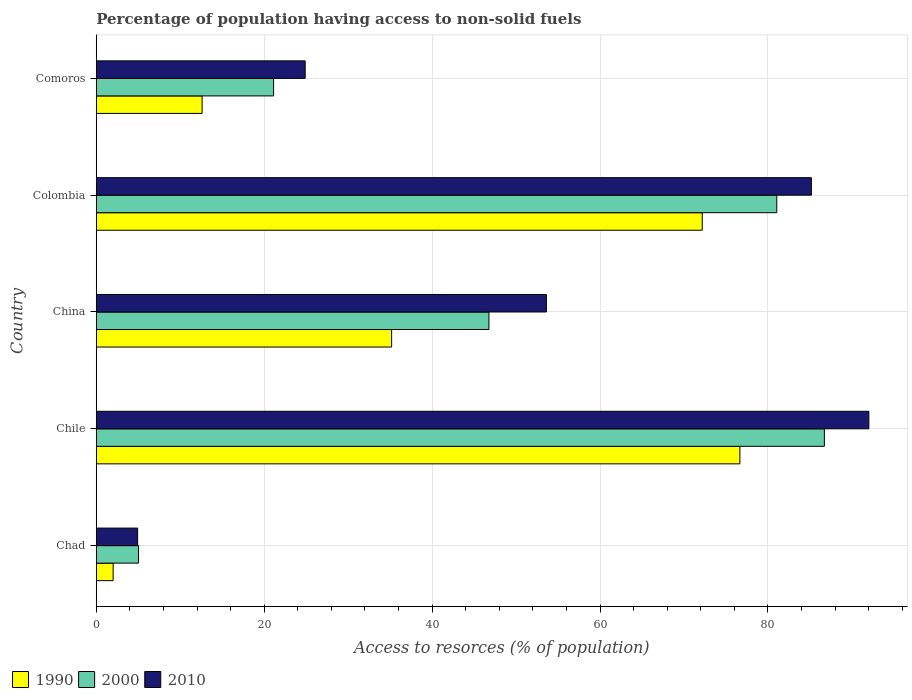How many groups of bars are there?
Offer a terse response. 5. How many bars are there on the 2nd tick from the top?
Your answer should be very brief. 3. What is the label of the 3rd group of bars from the top?
Give a very brief answer. China. What is the percentage of population having access to non-solid fuels in 1990 in China?
Ensure brevity in your answer.  35.18. Across all countries, what is the maximum percentage of population having access to non-solid fuels in 1990?
Offer a very short reply. 76.66. Across all countries, what is the minimum percentage of population having access to non-solid fuels in 2010?
Keep it short and to the point. 4.92. In which country was the percentage of population having access to non-solid fuels in 2010 maximum?
Give a very brief answer. Chile. In which country was the percentage of population having access to non-solid fuels in 2000 minimum?
Your answer should be very brief. Chad. What is the total percentage of population having access to non-solid fuels in 2010 in the graph?
Offer a very short reply. 260.61. What is the difference between the percentage of population having access to non-solid fuels in 2010 in Chile and that in Colombia?
Give a very brief answer. 6.85. What is the difference between the percentage of population having access to non-solid fuels in 1990 in China and the percentage of population having access to non-solid fuels in 2000 in Colombia?
Provide a succinct answer. -45.87. What is the average percentage of population having access to non-solid fuels in 2000 per country?
Offer a terse response. 48.14. What is the difference between the percentage of population having access to non-solid fuels in 1990 and percentage of population having access to non-solid fuels in 2010 in China?
Your response must be concise. -18.43. In how many countries, is the percentage of population having access to non-solid fuels in 2010 greater than 44 %?
Your answer should be very brief. 3. What is the ratio of the percentage of population having access to non-solid fuels in 2010 in China to that in Colombia?
Keep it short and to the point. 0.63. Is the percentage of population having access to non-solid fuels in 2010 in Chad less than that in Colombia?
Your answer should be very brief. Yes. Is the difference between the percentage of population having access to non-solid fuels in 1990 in Chile and Colombia greater than the difference between the percentage of population having access to non-solid fuels in 2010 in Chile and Colombia?
Provide a succinct answer. No. What is the difference between the highest and the second highest percentage of population having access to non-solid fuels in 1990?
Give a very brief answer. 4.49. What is the difference between the highest and the lowest percentage of population having access to non-solid fuels in 2010?
Your response must be concise. 87.09. In how many countries, is the percentage of population having access to non-solid fuels in 2000 greater than the average percentage of population having access to non-solid fuels in 2000 taken over all countries?
Offer a terse response. 2. Is the sum of the percentage of population having access to non-solid fuels in 2010 in Chile and China greater than the maximum percentage of population having access to non-solid fuels in 2000 across all countries?
Give a very brief answer. Yes. What does the 1st bar from the top in Chad represents?
Ensure brevity in your answer.  2010. What does the 3rd bar from the bottom in China represents?
Offer a terse response. 2010. Is it the case that in every country, the sum of the percentage of population having access to non-solid fuels in 1990 and percentage of population having access to non-solid fuels in 2010 is greater than the percentage of population having access to non-solid fuels in 2000?
Ensure brevity in your answer.  Yes. What is the difference between two consecutive major ticks on the X-axis?
Provide a succinct answer. 20. Are the values on the major ticks of X-axis written in scientific E-notation?
Offer a very short reply. No. Where does the legend appear in the graph?
Provide a short and direct response. Bottom left. How many legend labels are there?
Ensure brevity in your answer.  3. How are the legend labels stacked?
Your answer should be very brief. Horizontal. What is the title of the graph?
Offer a very short reply. Percentage of population having access to non-solid fuels. Does "1998" appear as one of the legend labels in the graph?
Your answer should be very brief. No. What is the label or title of the X-axis?
Your answer should be very brief. Access to resorces (% of population). What is the label or title of the Y-axis?
Ensure brevity in your answer.  Country. What is the Access to resorces (% of population) in 1990 in Chad?
Give a very brief answer. 2.01. What is the Access to resorces (% of population) in 2000 in Chad?
Your answer should be compact. 5.04. What is the Access to resorces (% of population) in 2010 in Chad?
Your response must be concise. 4.92. What is the Access to resorces (% of population) of 1990 in Chile?
Ensure brevity in your answer.  76.66. What is the Access to resorces (% of population) of 2000 in Chile?
Keep it short and to the point. 86.72. What is the Access to resorces (% of population) of 2010 in Chile?
Offer a terse response. 92.02. What is the Access to resorces (% of population) in 1990 in China?
Your response must be concise. 35.18. What is the Access to resorces (% of population) in 2000 in China?
Your response must be concise. 46.77. What is the Access to resorces (% of population) of 2010 in China?
Your answer should be very brief. 53.61. What is the Access to resorces (% of population) of 1990 in Colombia?
Your response must be concise. 72.17. What is the Access to resorces (% of population) in 2000 in Colombia?
Offer a terse response. 81.05. What is the Access to resorces (% of population) in 2010 in Colombia?
Your answer should be compact. 85.17. What is the Access to resorces (% of population) of 1990 in Comoros?
Provide a succinct answer. 12.61. What is the Access to resorces (% of population) in 2000 in Comoros?
Your answer should be very brief. 21.12. What is the Access to resorces (% of population) of 2010 in Comoros?
Keep it short and to the point. 24.88. Across all countries, what is the maximum Access to resorces (% of population) in 1990?
Ensure brevity in your answer.  76.66. Across all countries, what is the maximum Access to resorces (% of population) in 2000?
Keep it short and to the point. 86.72. Across all countries, what is the maximum Access to resorces (% of population) in 2010?
Ensure brevity in your answer.  92.02. Across all countries, what is the minimum Access to resorces (% of population) in 1990?
Provide a short and direct response. 2.01. Across all countries, what is the minimum Access to resorces (% of population) of 2000?
Keep it short and to the point. 5.04. Across all countries, what is the minimum Access to resorces (% of population) in 2010?
Ensure brevity in your answer.  4.92. What is the total Access to resorces (% of population) of 1990 in the graph?
Keep it short and to the point. 198.62. What is the total Access to resorces (% of population) in 2000 in the graph?
Give a very brief answer. 240.69. What is the total Access to resorces (% of population) in 2010 in the graph?
Your answer should be compact. 260.61. What is the difference between the Access to resorces (% of population) of 1990 in Chad and that in Chile?
Make the answer very short. -74.65. What is the difference between the Access to resorces (% of population) of 2000 in Chad and that in Chile?
Offer a terse response. -81.68. What is the difference between the Access to resorces (% of population) of 2010 in Chad and that in Chile?
Your response must be concise. -87.09. What is the difference between the Access to resorces (% of population) in 1990 in Chad and that in China?
Your response must be concise. -33.17. What is the difference between the Access to resorces (% of population) of 2000 in Chad and that in China?
Your answer should be compact. -41.73. What is the difference between the Access to resorces (% of population) of 2010 in Chad and that in China?
Your answer should be compact. -48.69. What is the difference between the Access to resorces (% of population) in 1990 in Chad and that in Colombia?
Keep it short and to the point. -70.16. What is the difference between the Access to resorces (% of population) in 2000 in Chad and that in Colombia?
Offer a very short reply. -76.01. What is the difference between the Access to resorces (% of population) of 2010 in Chad and that in Colombia?
Make the answer very short. -80.25. What is the difference between the Access to resorces (% of population) in 1990 in Chad and that in Comoros?
Your response must be concise. -10.6. What is the difference between the Access to resorces (% of population) in 2000 in Chad and that in Comoros?
Provide a short and direct response. -16.09. What is the difference between the Access to resorces (% of population) in 2010 in Chad and that in Comoros?
Your answer should be very brief. -19.96. What is the difference between the Access to resorces (% of population) of 1990 in Chile and that in China?
Offer a very short reply. 41.48. What is the difference between the Access to resorces (% of population) of 2000 in Chile and that in China?
Your answer should be very brief. 39.95. What is the difference between the Access to resorces (% of population) of 2010 in Chile and that in China?
Provide a short and direct response. 38.41. What is the difference between the Access to resorces (% of population) in 1990 in Chile and that in Colombia?
Provide a short and direct response. 4.49. What is the difference between the Access to resorces (% of population) in 2000 in Chile and that in Colombia?
Provide a short and direct response. 5.67. What is the difference between the Access to resorces (% of population) of 2010 in Chile and that in Colombia?
Your response must be concise. 6.85. What is the difference between the Access to resorces (% of population) in 1990 in Chile and that in Comoros?
Your answer should be compact. 64.05. What is the difference between the Access to resorces (% of population) in 2000 in Chile and that in Comoros?
Make the answer very short. 65.6. What is the difference between the Access to resorces (% of population) in 2010 in Chile and that in Comoros?
Your answer should be very brief. 67.13. What is the difference between the Access to resorces (% of population) in 1990 in China and that in Colombia?
Provide a short and direct response. -36.99. What is the difference between the Access to resorces (% of population) of 2000 in China and that in Colombia?
Provide a short and direct response. -34.28. What is the difference between the Access to resorces (% of population) in 2010 in China and that in Colombia?
Offer a very short reply. -31.56. What is the difference between the Access to resorces (% of population) in 1990 in China and that in Comoros?
Keep it short and to the point. 22.57. What is the difference between the Access to resorces (% of population) of 2000 in China and that in Comoros?
Provide a short and direct response. 25.65. What is the difference between the Access to resorces (% of population) in 2010 in China and that in Comoros?
Your answer should be very brief. 28.73. What is the difference between the Access to resorces (% of population) of 1990 in Colombia and that in Comoros?
Your response must be concise. 59.57. What is the difference between the Access to resorces (% of population) in 2000 in Colombia and that in Comoros?
Keep it short and to the point. 59.93. What is the difference between the Access to resorces (% of population) in 2010 in Colombia and that in Comoros?
Offer a very short reply. 60.29. What is the difference between the Access to resorces (% of population) in 1990 in Chad and the Access to resorces (% of population) in 2000 in Chile?
Provide a succinct answer. -84.71. What is the difference between the Access to resorces (% of population) of 1990 in Chad and the Access to resorces (% of population) of 2010 in Chile?
Offer a very short reply. -90.01. What is the difference between the Access to resorces (% of population) of 2000 in Chad and the Access to resorces (% of population) of 2010 in Chile?
Give a very brief answer. -86.98. What is the difference between the Access to resorces (% of population) of 1990 in Chad and the Access to resorces (% of population) of 2000 in China?
Give a very brief answer. -44.76. What is the difference between the Access to resorces (% of population) of 1990 in Chad and the Access to resorces (% of population) of 2010 in China?
Your answer should be very brief. -51.6. What is the difference between the Access to resorces (% of population) in 2000 in Chad and the Access to resorces (% of population) in 2010 in China?
Your answer should be very brief. -48.58. What is the difference between the Access to resorces (% of population) of 1990 in Chad and the Access to resorces (% of population) of 2000 in Colombia?
Your response must be concise. -79.04. What is the difference between the Access to resorces (% of population) of 1990 in Chad and the Access to resorces (% of population) of 2010 in Colombia?
Provide a short and direct response. -83.16. What is the difference between the Access to resorces (% of population) in 2000 in Chad and the Access to resorces (% of population) in 2010 in Colombia?
Keep it short and to the point. -80.14. What is the difference between the Access to resorces (% of population) of 1990 in Chad and the Access to resorces (% of population) of 2000 in Comoros?
Your response must be concise. -19.11. What is the difference between the Access to resorces (% of population) in 1990 in Chad and the Access to resorces (% of population) in 2010 in Comoros?
Make the answer very short. -22.87. What is the difference between the Access to resorces (% of population) of 2000 in Chad and the Access to resorces (% of population) of 2010 in Comoros?
Make the answer very short. -19.85. What is the difference between the Access to resorces (% of population) in 1990 in Chile and the Access to resorces (% of population) in 2000 in China?
Offer a very short reply. 29.89. What is the difference between the Access to resorces (% of population) in 1990 in Chile and the Access to resorces (% of population) in 2010 in China?
Give a very brief answer. 23.05. What is the difference between the Access to resorces (% of population) of 2000 in Chile and the Access to resorces (% of population) of 2010 in China?
Offer a very short reply. 33.11. What is the difference between the Access to resorces (% of population) in 1990 in Chile and the Access to resorces (% of population) in 2000 in Colombia?
Provide a succinct answer. -4.39. What is the difference between the Access to resorces (% of population) of 1990 in Chile and the Access to resorces (% of population) of 2010 in Colombia?
Offer a very short reply. -8.51. What is the difference between the Access to resorces (% of population) in 2000 in Chile and the Access to resorces (% of population) in 2010 in Colombia?
Your response must be concise. 1.55. What is the difference between the Access to resorces (% of population) in 1990 in Chile and the Access to resorces (% of population) in 2000 in Comoros?
Offer a very short reply. 55.54. What is the difference between the Access to resorces (% of population) of 1990 in Chile and the Access to resorces (% of population) of 2010 in Comoros?
Make the answer very short. 51.77. What is the difference between the Access to resorces (% of population) in 2000 in Chile and the Access to resorces (% of population) in 2010 in Comoros?
Give a very brief answer. 61.84. What is the difference between the Access to resorces (% of population) of 1990 in China and the Access to resorces (% of population) of 2000 in Colombia?
Your answer should be compact. -45.87. What is the difference between the Access to resorces (% of population) of 1990 in China and the Access to resorces (% of population) of 2010 in Colombia?
Your response must be concise. -49.99. What is the difference between the Access to resorces (% of population) of 2000 in China and the Access to resorces (% of population) of 2010 in Colombia?
Provide a short and direct response. -38.4. What is the difference between the Access to resorces (% of population) in 1990 in China and the Access to resorces (% of population) in 2000 in Comoros?
Keep it short and to the point. 14.06. What is the difference between the Access to resorces (% of population) of 1990 in China and the Access to resorces (% of population) of 2010 in Comoros?
Offer a very short reply. 10.29. What is the difference between the Access to resorces (% of population) in 2000 in China and the Access to resorces (% of population) in 2010 in Comoros?
Give a very brief answer. 21.88. What is the difference between the Access to resorces (% of population) in 1990 in Colombia and the Access to resorces (% of population) in 2000 in Comoros?
Your answer should be compact. 51.05. What is the difference between the Access to resorces (% of population) of 1990 in Colombia and the Access to resorces (% of population) of 2010 in Comoros?
Make the answer very short. 47.29. What is the difference between the Access to resorces (% of population) of 2000 in Colombia and the Access to resorces (% of population) of 2010 in Comoros?
Offer a terse response. 56.16. What is the average Access to resorces (% of population) of 1990 per country?
Your response must be concise. 39.72. What is the average Access to resorces (% of population) of 2000 per country?
Give a very brief answer. 48.14. What is the average Access to resorces (% of population) of 2010 per country?
Provide a short and direct response. 52.12. What is the difference between the Access to resorces (% of population) in 1990 and Access to resorces (% of population) in 2000 in Chad?
Your answer should be compact. -3.03. What is the difference between the Access to resorces (% of population) in 1990 and Access to resorces (% of population) in 2010 in Chad?
Make the answer very short. -2.92. What is the difference between the Access to resorces (% of population) in 2000 and Access to resorces (% of population) in 2010 in Chad?
Your response must be concise. 0.11. What is the difference between the Access to resorces (% of population) of 1990 and Access to resorces (% of population) of 2000 in Chile?
Offer a very short reply. -10.06. What is the difference between the Access to resorces (% of population) in 1990 and Access to resorces (% of population) in 2010 in Chile?
Your answer should be compact. -15.36. What is the difference between the Access to resorces (% of population) of 2000 and Access to resorces (% of population) of 2010 in Chile?
Offer a terse response. -5.3. What is the difference between the Access to resorces (% of population) of 1990 and Access to resorces (% of population) of 2000 in China?
Keep it short and to the point. -11.59. What is the difference between the Access to resorces (% of population) of 1990 and Access to resorces (% of population) of 2010 in China?
Your answer should be compact. -18.43. What is the difference between the Access to resorces (% of population) in 2000 and Access to resorces (% of population) in 2010 in China?
Provide a succinct answer. -6.84. What is the difference between the Access to resorces (% of population) in 1990 and Access to resorces (% of population) in 2000 in Colombia?
Offer a terse response. -8.88. What is the difference between the Access to resorces (% of population) of 1990 and Access to resorces (% of population) of 2010 in Colombia?
Provide a short and direct response. -13. What is the difference between the Access to resorces (% of population) of 2000 and Access to resorces (% of population) of 2010 in Colombia?
Offer a very short reply. -4.12. What is the difference between the Access to resorces (% of population) of 1990 and Access to resorces (% of population) of 2000 in Comoros?
Your answer should be very brief. -8.52. What is the difference between the Access to resorces (% of population) in 1990 and Access to resorces (% of population) in 2010 in Comoros?
Give a very brief answer. -12.28. What is the difference between the Access to resorces (% of population) of 2000 and Access to resorces (% of population) of 2010 in Comoros?
Your response must be concise. -3.76. What is the ratio of the Access to resorces (% of population) of 1990 in Chad to that in Chile?
Your answer should be compact. 0.03. What is the ratio of the Access to resorces (% of population) of 2000 in Chad to that in Chile?
Your response must be concise. 0.06. What is the ratio of the Access to resorces (% of population) in 2010 in Chad to that in Chile?
Your response must be concise. 0.05. What is the ratio of the Access to resorces (% of population) of 1990 in Chad to that in China?
Your answer should be compact. 0.06. What is the ratio of the Access to resorces (% of population) in 2000 in Chad to that in China?
Provide a succinct answer. 0.11. What is the ratio of the Access to resorces (% of population) in 2010 in Chad to that in China?
Offer a very short reply. 0.09. What is the ratio of the Access to resorces (% of population) in 1990 in Chad to that in Colombia?
Your response must be concise. 0.03. What is the ratio of the Access to resorces (% of population) in 2000 in Chad to that in Colombia?
Provide a succinct answer. 0.06. What is the ratio of the Access to resorces (% of population) in 2010 in Chad to that in Colombia?
Provide a short and direct response. 0.06. What is the ratio of the Access to resorces (% of population) in 1990 in Chad to that in Comoros?
Ensure brevity in your answer.  0.16. What is the ratio of the Access to resorces (% of population) in 2000 in Chad to that in Comoros?
Offer a very short reply. 0.24. What is the ratio of the Access to resorces (% of population) of 2010 in Chad to that in Comoros?
Keep it short and to the point. 0.2. What is the ratio of the Access to resorces (% of population) of 1990 in Chile to that in China?
Provide a succinct answer. 2.18. What is the ratio of the Access to resorces (% of population) in 2000 in Chile to that in China?
Your answer should be very brief. 1.85. What is the ratio of the Access to resorces (% of population) of 2010 in Chile to that in China?
Keep it short and to the point. 1.72. What is the ratio of the Access to resorces (% of population) in 1990 in Chile to that in Colombia?
Give a very brief answer. 1.06. What is the ratio of the Access to resorces (% of population) of 2000 in Chile to that in Colombia?
Keep it short and to the point. 1.07. What is the ratio of the Access to resorces (% of population) of 2010 in Chile to that in Colombia?
Give a very brief answer. 1.08. What is the ratio of the Access to resorces (% of population) of 1990 in Chile to that in Comoros?
Keep it short and to the point. 6.08. What is the ratio of the Access to resorces (% of population) in 2000 in Chile to that in Comoros?
Your answer should be very brief. 4.11. What is the ratio of the Access to resorces (% of population) of 2010 in Chile to that in Comoros?
Your answer should be compact. 3.7. What is the ratio of the Access to resorces (% of population) in 1990 in China to that in Colombia?
Ensure brevity in your answer.  0.49. What is the ratio of the Access to resorces (% of population) in 2000 in China to that in Colombia?
Your response must be concise. 0.58. What is the ratio of the Access to resorces (% of population) in 2010 in China to that in Colombia?
Ensure brevity in your answer.  0.63. What is the ratio of the Access to resorces (% of population) in 1990 in China to that in Comoros?
Provide a short and direct response. 2.79. What is the ratio of the Access to resorces (% of population) in 2000 in China to that in Comoros?
Make the answer very short. 2.21. What is the ratio of the Access to resorces (% of population) in 2010 in China to that in Comoros?
Offer a very short reply. 2.15. What is the ratio of the Access to resorces (% of population) in 1990 in Colombia to that in Comoros?
Offer a terse response. 5.73. What is the ratio of the Access to resorces (% of population) of 2000 in Colombia to that in Comoros?
Your response must be concise. 3.84. What is the ratio of the Access to resorces (% of population) in 2010 in Colombia to that in Comoros?
Offer a very short reply. 3.42. What is the difference between the highest and the second highest Access to resorces (% of population) in 1990?
Make the answer very short. 4.49. What is the difference between the highest and the second highest Access to resorces (% of population) of 2000?
Your response must be concise. 5.67. What is the difference between the highest and the second highest Access to resorces (% of population) of 2010?
Make the answer very short. 6.85. What is the difference between the highest and the lowest Access to resorces (% of population) in 1990?
Keep it short and to the point. 74.65. What is the difference between the highest and the lowest Access to resorces (% of population) in 2000?
Your response must be concise. 81.68. What is the difference between the highest and the lowest Access to resorces (% of population) in 2010?
Your response must be concise. 87.09. 